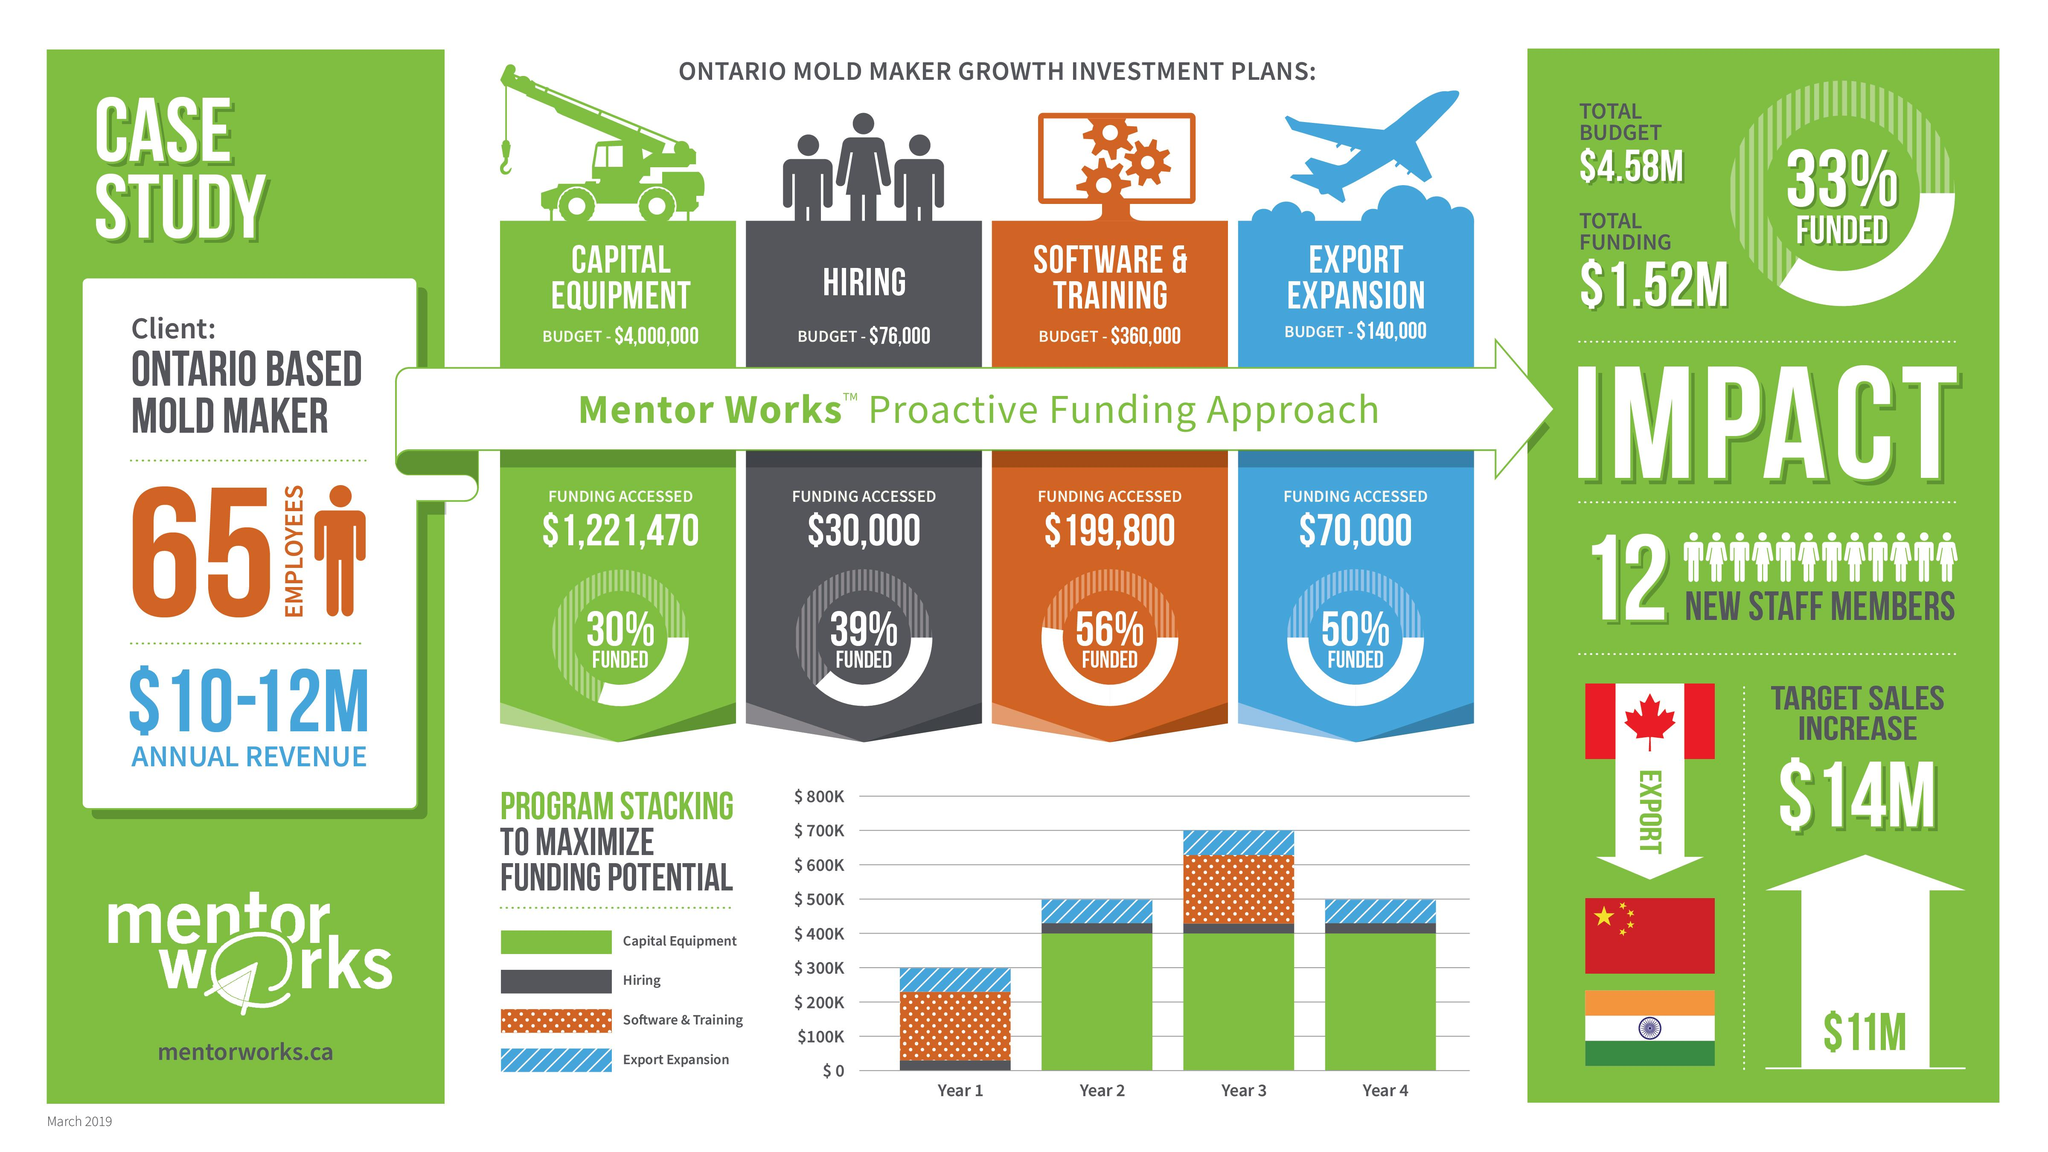Identify some key points in this picture. Approximately 30% of the capital equipment funding is accessed by the Ontario-based mold maker. The budget for an Ontario-based mold maker in its export expansion initiative is $140,000. The Ontario-based mold maker has allocated a budget of $360,000 for software and training in the current fiscal year. The budget of an Ontario-based mold maker for hiring employees is $76,000. The Ontario-based mold maker accessed 56% of their funding for software and training. 